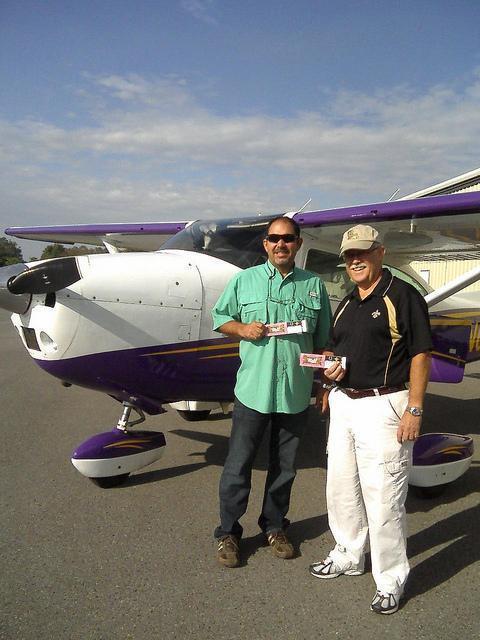How many people are in the photo?
Give a very brief answer. 2. 